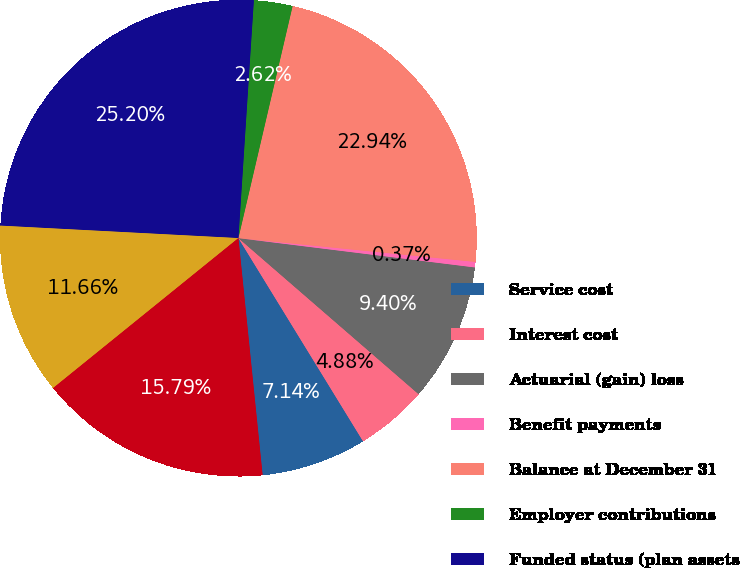<chart> <loc_0><loc_0><loc_500><loc_500><pie_chart><fcel>Service cost<fcel>Interest cost<fcel>Actuarial (gain) loss<fcel>Benefit payments<fcel>Balance at December 31<fcel>Employer contributions<fcel>Funded status (plan assets<fcel>Unrecognized net actuarial<fcel>Net amount recognized<nl><fcel>7.14%<fcel>4.88%<fcel>9.4%<fcel>0.37%<fcel>22.94%<fcel>2.62%<fcel>25.2%<fcel>11.66%<fcel>15.79%<nl></chart> 